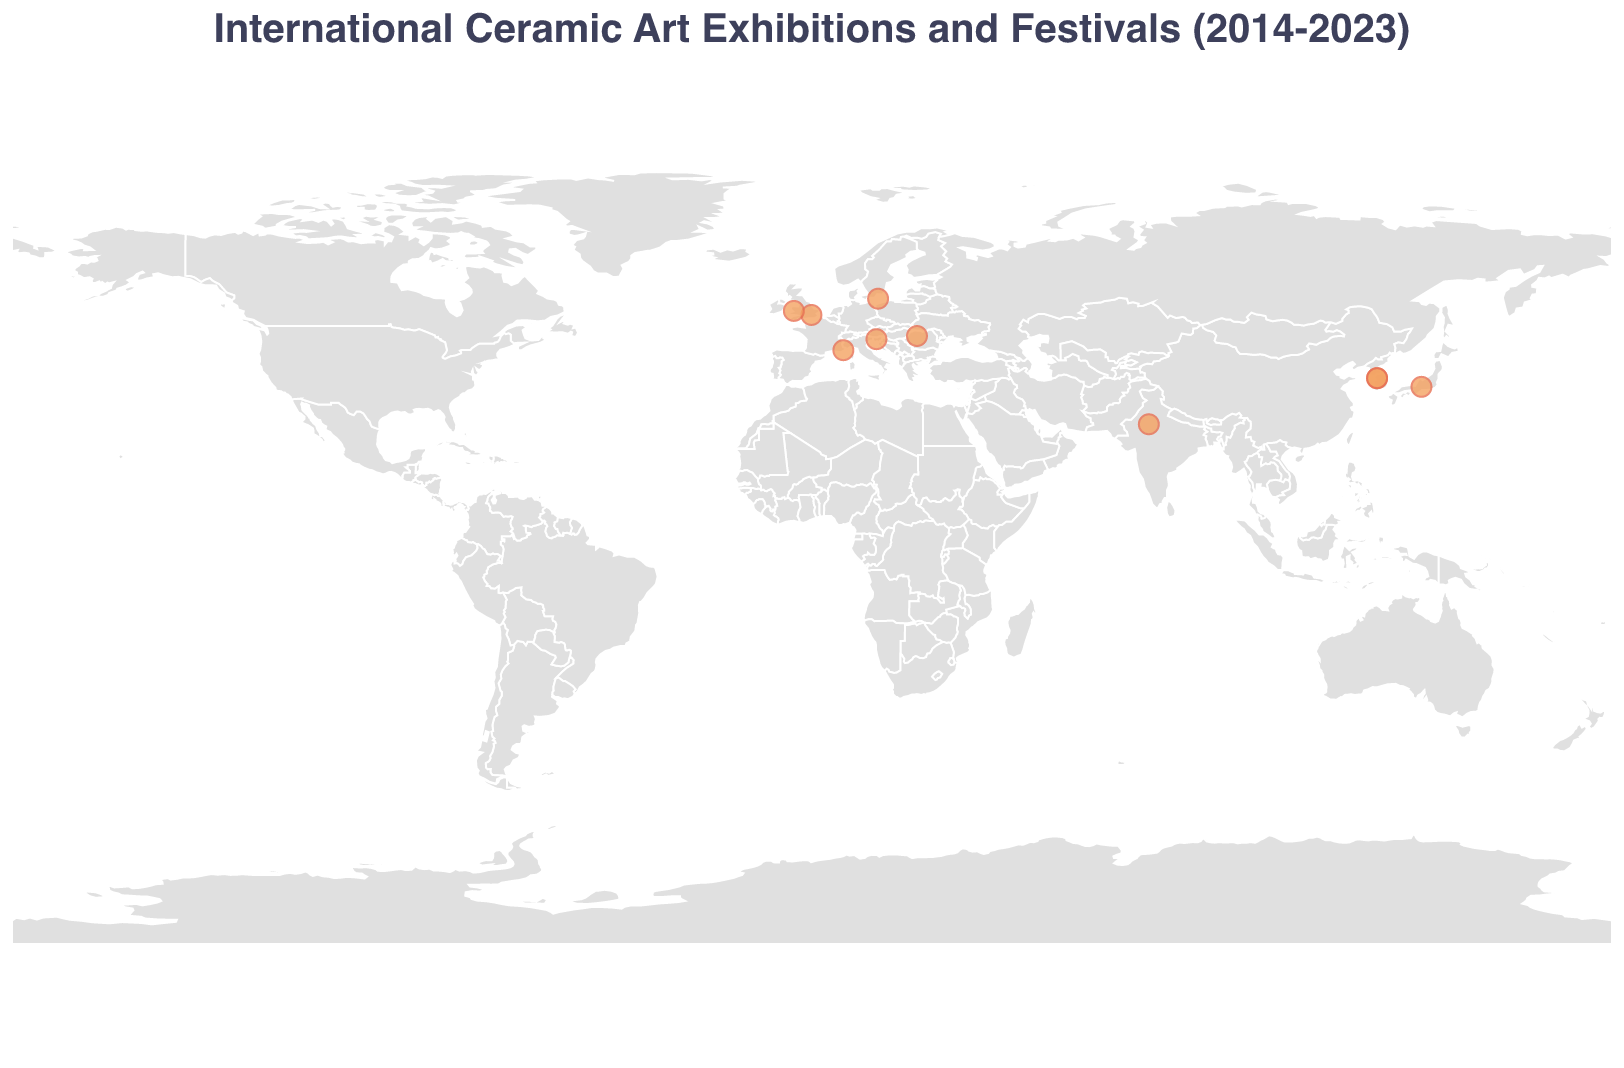What is the title of the figure? The title is usually placed at the top or prominently displayed to provide the viewers with context about what the figure represents. In this case, it is clearly shown at the top of the figure.
Answer: International Ceramic Art Exhibitions and Festivals (2014-2023) How many events took place in the United Kingdom? Look at the tooltip information for each circle on the map and count the number of times "United Kingdom" appears in the "Country" field.
Answer: 2 Which event is located furthest south? Find the latitude values of each event from the tooltip data displayed on the map and identify the event with the smallest latitude value, as the southern hemisphere has negative latitude values.
Answer: Indian Ceramics Triennale What is the average year of all the events listed? Sum the years for all events and then divide by the number of events. Calculation: (2014 + 2015 + 2016 + 2017 + 2018 + 2019 + 2020 + 2021 + 2022 + 2023) / 10 = 2018.5
Answer: 2018.5 Are there any events that took place in the same city? If yes, which ones? Check the city information in the tooltip for each circle and see if any cities are repeated.
Answer: Yes, Icheon, South Korea Which event occurred in 2020? Hover over the circles to see the tooltip data and identify the event corresponding to the year 2020.
Answer: Mino Ceramic Art Festival How many events took place in Asia? Identify which countries listed are in Asia (South Korea, Japan, India) and count the events in these countries. Komachi: South Korea (2 events), Japan (1 event), India (1 event). Total: 2 + 1 + 1 = 4
Answer: 4 Which event is closest to the equator? Compare the latitude values available in the tooltip of each event to find the one closest to zero (the equator is at 0 latitude).
Answer: Indian Ceramics Triennale In which country did the Vallauris Biennale take place? Check the tooltip information on the map and see where the Vallauris Biennale is listed. The country information is directly provided.
Answer: France Which continent has the highest number of ceramic art exhibitions and festivals in this figure? By reviewing each event's location, categorize them into continents (Europe, Asia). Europe has the United Kingdom (2), Denmark (1), Romania (1), France (1), Slovenia (1), totaling 6. Asia has South Korea (2), Japan (1), India (1), totaling 4.
Answer: Europe 